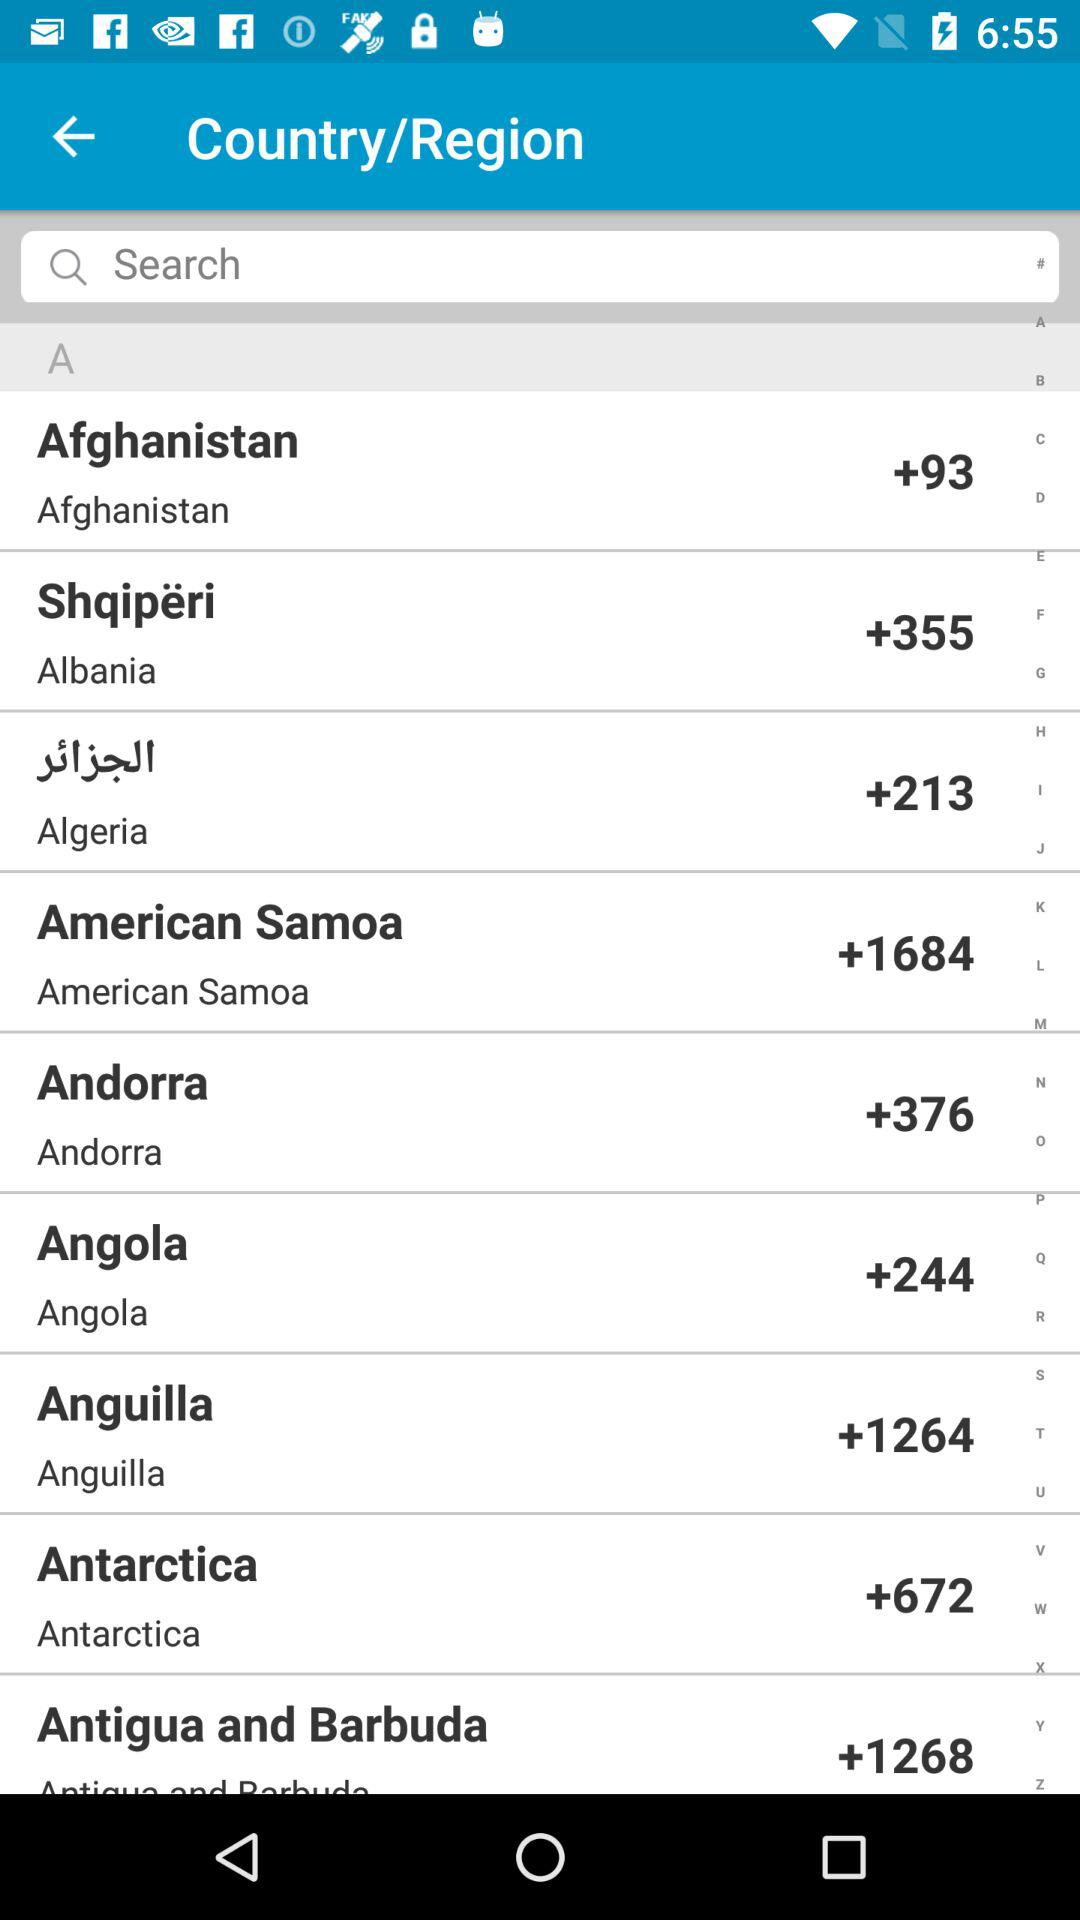What is the code for American Samoa? The code for American Samoa is +1684. 